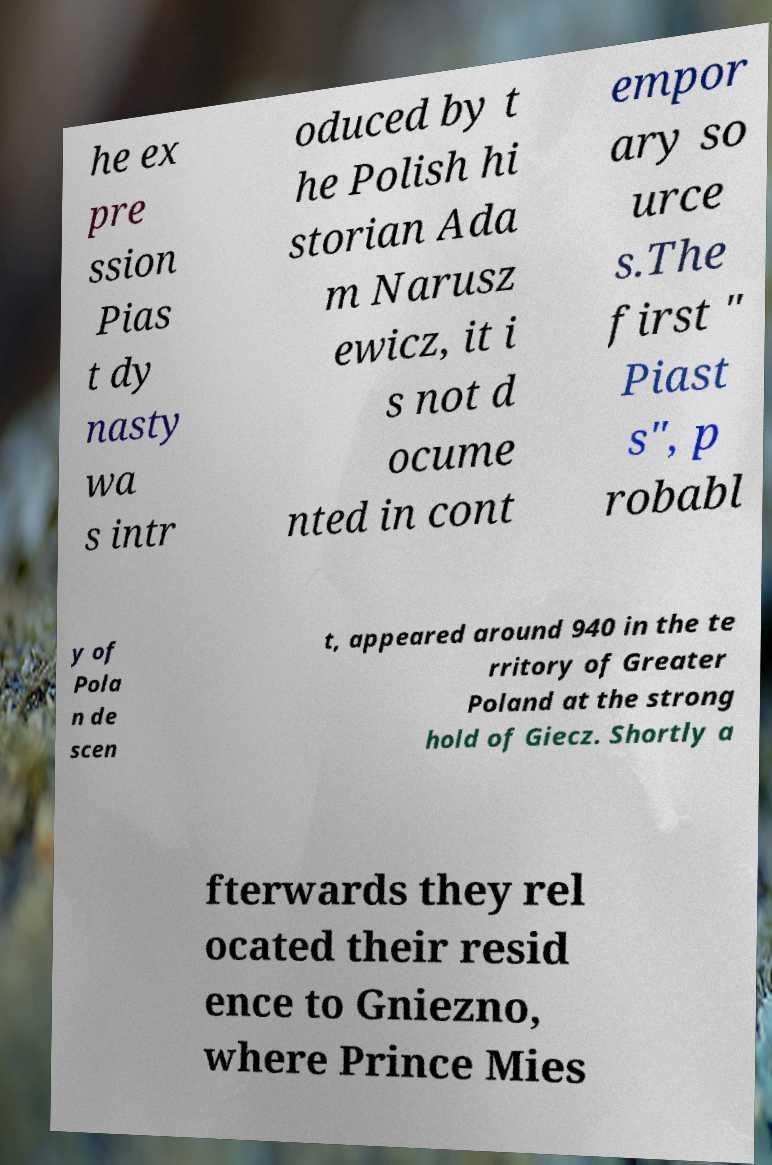What messages or text are displayed in this image? I need them in a readable, typed format. he ex pre ssion Pias t dy nasty wa s intr oduced by t he Polish hi storian Ada m Narusz ewicz, it i s not d ocume nted in cont empor ary so urce s.The first " Piast s", p robabl y of Pola n de scen t, appeared around 940 in the te rritory of Greater Poland at the strong hold of Giecz. Shortly a fterwards they rel ocated their resid ence to Gniezno, where Prince Mies 